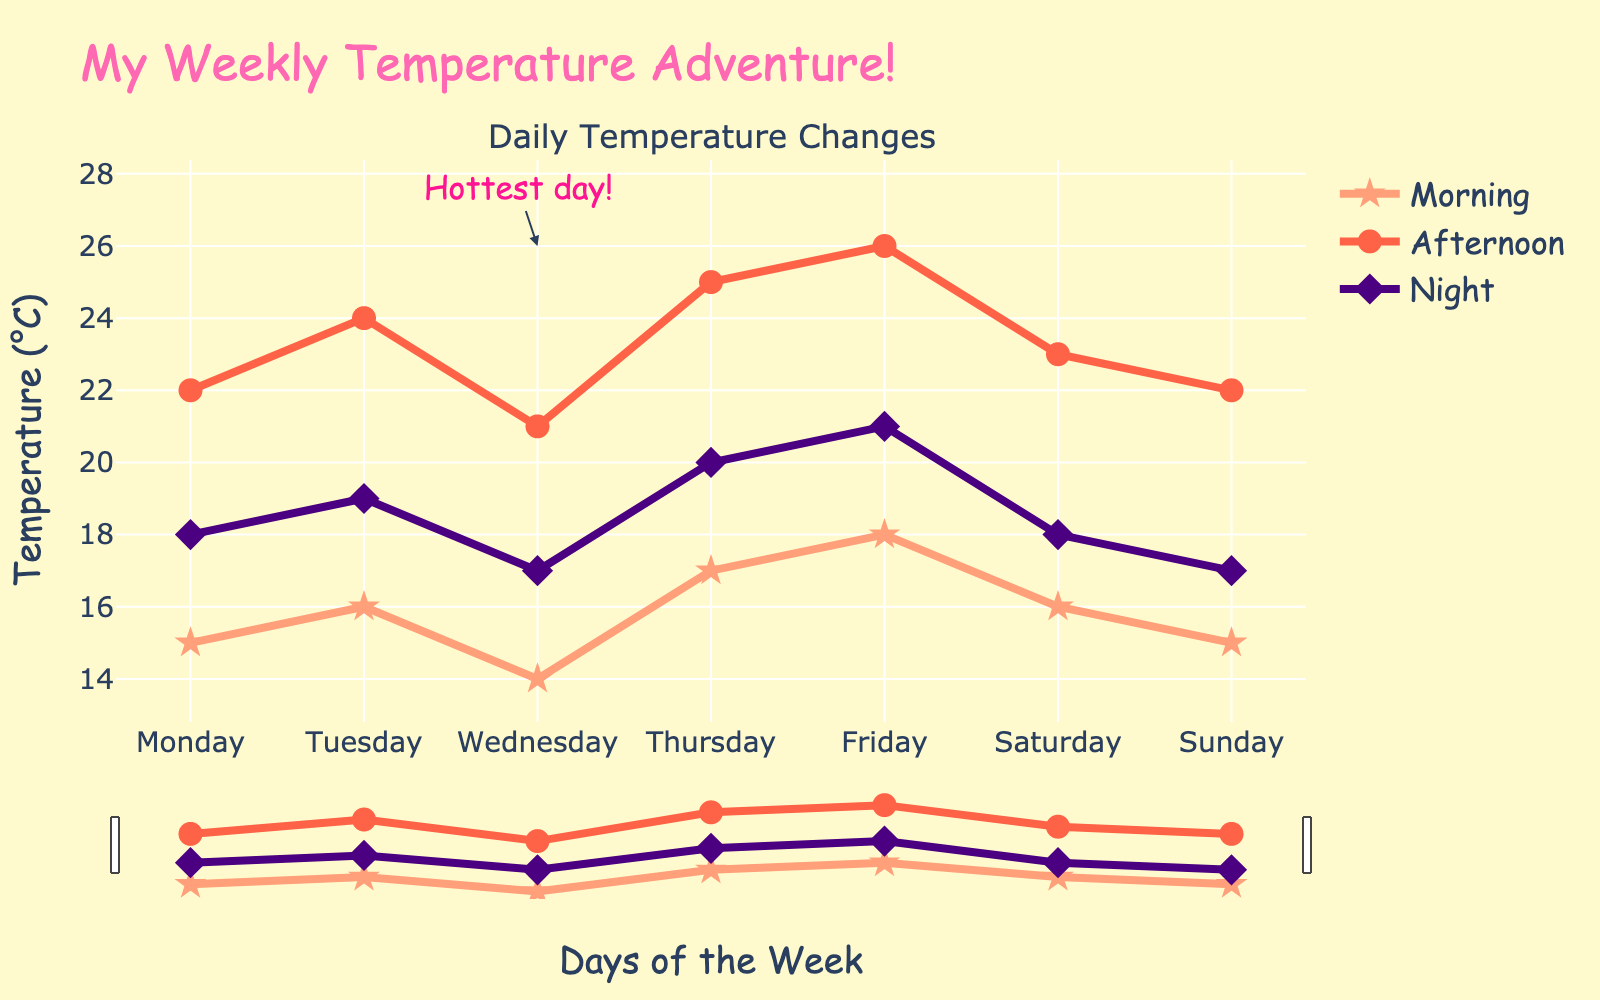What's the highest temperature recorded in the week? The highest temperature recorded appears on Friday afternoon, which is shown by the highest point on the red line.
Answer: 26°C Which day had the lowest morning temperature, and what was it? By looking at the orange line, the lowest morning temperature is on Wednesday, and it is 14°C.
Answer: Wednesday, 14°C What is the average nighttime temperature for the week? Add up all the nighttime temperatures: 18 + 19 + 17 + 20 + 21 + 18 + 17 = 130. Then divide by the number of days: 130 / 7 ≈ 18.57.
Answer: 18.57°C Which day had the biggest difference between morning and afternoon temperatures? For each day, calculate the difference between afternoon and morning: Monday (22-15=7), Tuesday (24-16=8), Wednesday (21-14=7), Thursday (25-17=8), Friday (26-18=8), Saturday (23-16=7), Sunday (22-15=7). The days with the biggest difference are Tuesday, Thursday, and Friday, each with an 8-degree difference.
Answer: Tuesday, Thursday, Friday Compare the temperatures on Monday and Wednesday in the afternoon. Which day was hotter? Look at the red line displaying the afternoon temperatures: Monday is 22°C and Wednesday is 21°C. So, Monday was hotter.
Answer: Monday Is the nighttime temperature always lower than the afternoon temperature on every day of the week? Compare each day’s nighttime temperature with its corresponding afternoon temperature: Yes, on Monday (18<22), Tuesday (19<24), Wednesday (17<21), Thursday (20<25), Friday (21<26), Saturday (18<23), and Sunday (17<22), the nighttime temperature is always lower.
Answer: Yes Which days have the same morning temperature of 15°C? Check the orange line for temperature values of 15°C: Monday and Sunday both have morning temperatures of 15°C.
Answer: Monday, Sunday What is the total increase in morning temperature from Monday to Friday? Calculate the difference in morning temperature from Monday to Friday: 18 - 15 = 3.
Answer: 3°C If the daytime temperature is the sum of the morning and afternoon temperatures, which day has the highest daytime temperature? Sum the morning and afternoon temperatures for each day: 
Monday (15+22=37), Tuesday (16+24=40), Wednesday (14+21=35), Thursday (17+25=42), Friday (18+26=44), Saturday (16+23=39), Sunday (15+22=37). The highest daytime temperature is on Friday.
Answer: Friday What color represents the night temperature trendline on the chart? The night temperature trendline is represented by the purple line on the chart.
Answer: Purple 